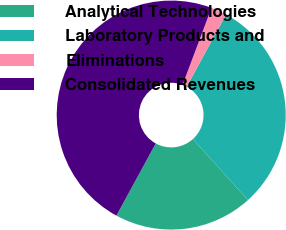Convert chart. <chart><loc_0><loc_0><loc_500><loc_500><pie_chart><fcel>Analytical Technologies<fcel>Laboratory Products and<fcel>Eliminations<fcel>Consolidated Revenues<nl><fcel>19.63%<fcel>30.37%<fcel>2.22%<fcel>47.78%<nl></chart> 